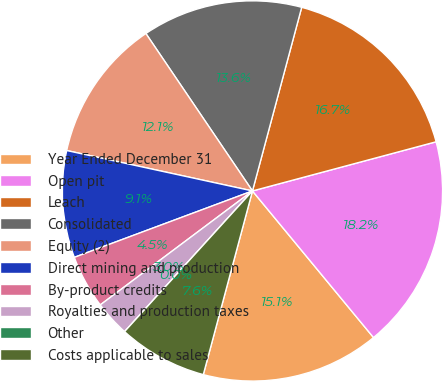<chart> <loc_0><loc_0><loc_500><loc_500><pie_chart><fcel>Year Ended December 31<fcel>Open pit<fcel>Leach<fcel>Consolidated<fcel>Equity (2)<fcel>Direct mining and production<fcel>By-product credits<fcel>Royalties and production taxes<fcel>Other<fcel>Costs applicable to sales<nl><fcel>15.15%<fcel>18.18%<fcel>16.67%<fcel>13.64%<fcel>12.12%<fcel>9.09%<fcel>4.55%<fcel>3.03%<fcel>0.0%<fcel>7.58%<nl></chart> 